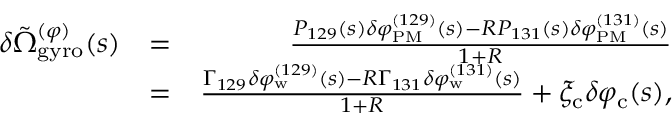Convert formula to latex. <formula><loc_0><loc_0><loc_500><loc_500>\begin{array} { r l r } { \delta \tilde { \Omega } _ { g y r o } ^ { ( \varphi ) } ( s ) } & { = } & { \frac { P _ { 1 2 9 } ( s ) \delta \varphi _ { P M } ^ { ( 1 2 9 ) } ( s ) - R P _ { 1 3 1 } ( s ) \delta \varphi _ { P M } ^ { ( 1 3 1 ) } ( s ) } { 1 + R } } \\ & { = } & { \frac { \Gamma _ { 1 2 9 } \delta \varphi _ { w } ^ { ( 1 2 9 ) } ( s ) - R \Gamma _ { 1 3 1 } \delta \varphi _ { w } ^ { ( 1 3 1 ) } ( s ) } { 1 + R } + \xi _ { c } \delta \varphi _ { c } ( s ) , } \end{array}</formula> 